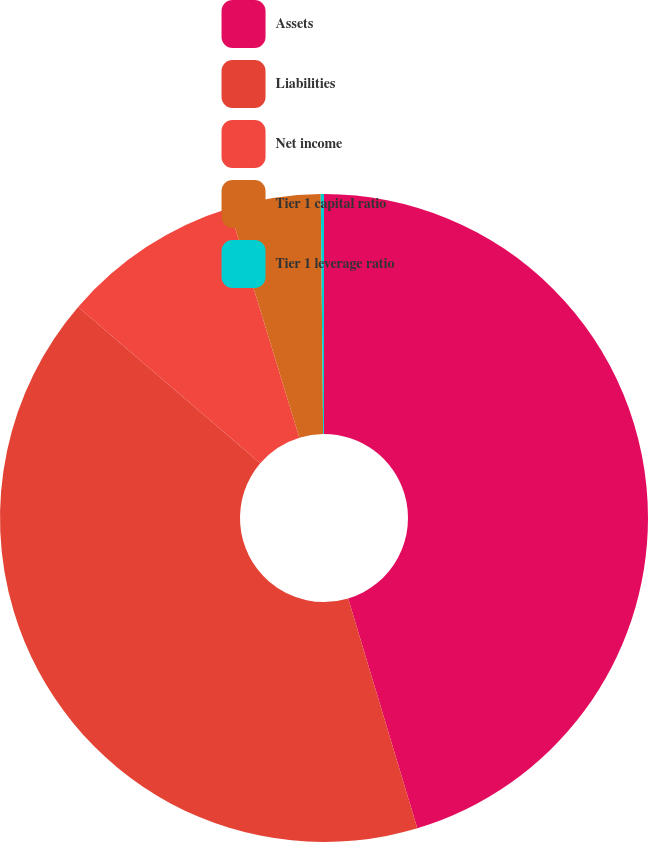Convert chart. <chart><loc_0><loc_0><loc_500><loc_500><pie_chart><fcel>Assets<fcel>Liabilities<fcel>Net income<fcel>Tier 1 capital ratio<fcel>Tier 1 leverage ratio<nl><fcel>45.35%<fcel>40.94%<fcel>8.98%<fcel>4.57%<fcel>0.16%<nl></chart> 